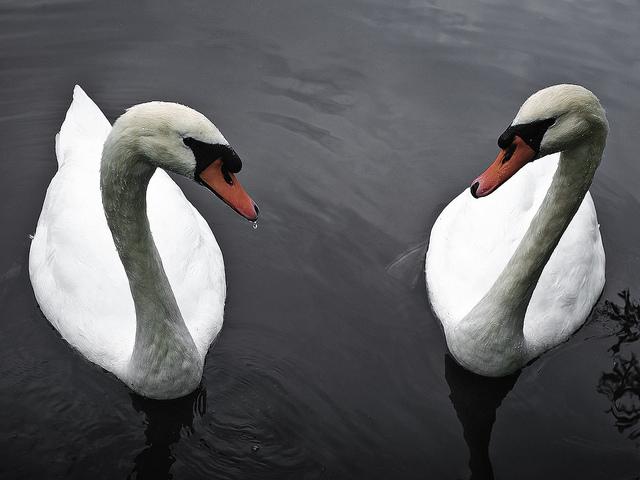Does this bird have a large beak?
Keep it brief. Yes. What color are the birds?
Keep it brief. White. Is it sunny?
Quick response, please. Yes. How many birds?
Concise answer only. 2. What are these animals on top of?
Short answer required. Water. 